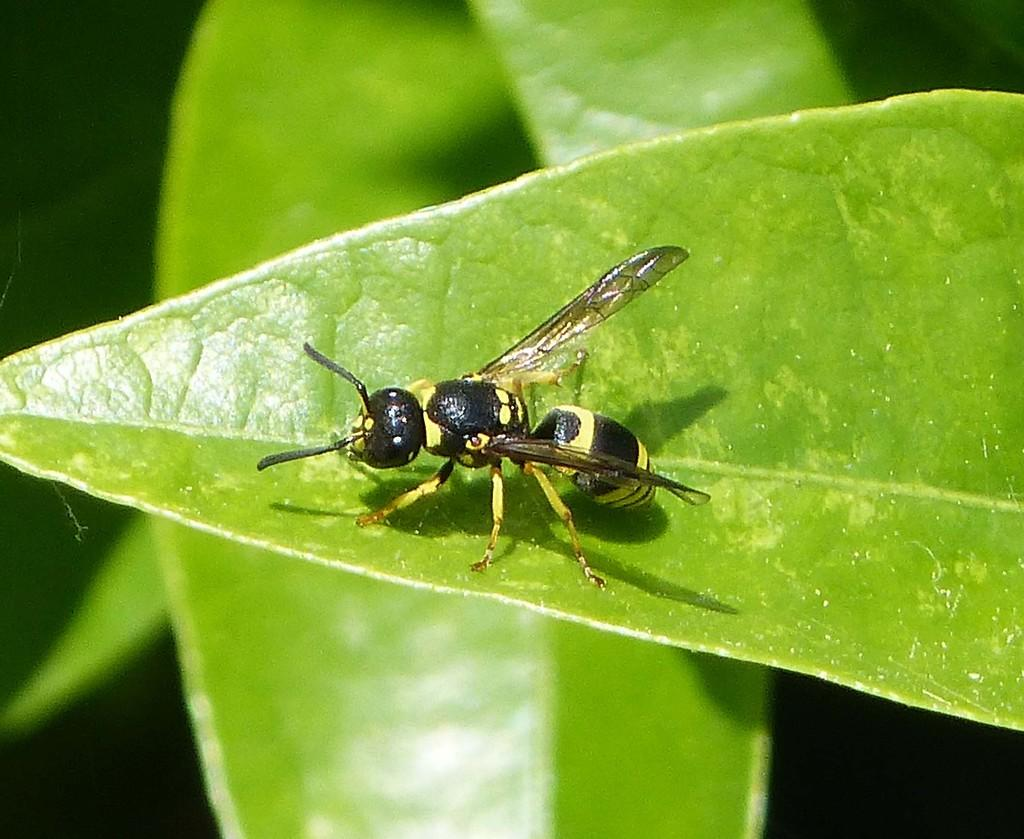What type of natural elements can be seen in the image? There are leaves in the image. Is there any living organism present on the leaves? Yes, there is an insect on one of the leaves. What can be seen in the background of the image? The background of the image is visible. Can you see the goldfish swimming in the image? There is no goldfish present in the image; it features leaves and an insect. Are there any snakes visible in the image? There are no snakes present in the image; it features leaves and an insect. 